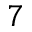<formula> <loc_0><loc_0><loc_500><loc_500>^ { 7 }</formula> 